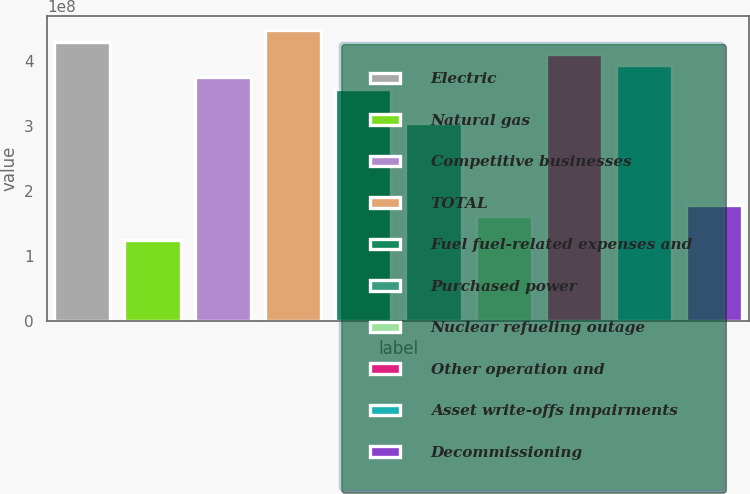Convert chart to OTSL. <chart><loc_0><loc_0><loc_500><loc_500><bar_chart><fcel>Electric<fcel>Natural gas<fcel>Competitive businesses<fcel>TOTAL<fcel>Fuel fuel-related expenses and<fcel>Purchased power<fcel>Nuclear refueling outage<fcel>Other operation and<fcel>Asset write-offs impairments<fcel>Decommissioning<nl><fcel>4.29326e+08<fcel>1.2522e+08<fcel>3.7566e+08<fcel>4.47214e+08<fcel>3.57771e+08<fcel>3.04106e+08<fcel>1.60997e+08<fcel>4.11437e+08<fcel>3.93548e+08<fcel>1.78886e+08<nl></chart> 